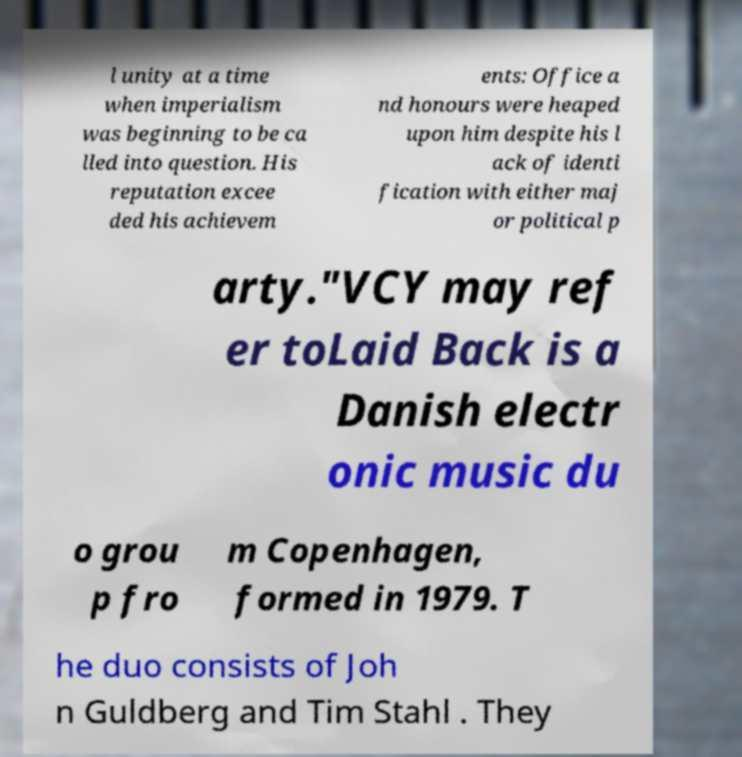There's text embedded in this image that I need extracted. Can you transcribe it verbatim? l unity at a time when imperialism was beginning to be ca lled into question. His reputation excee ded his achievem ents: Office a nd honours were heaped upon him despite his l ack of identi fication with either maj or political p arty."VCY may ref er toLaid Back is a Danish electr onic music du o grou p fro m Copenhagen, formed in 1979. T he duo consists of Joh n Guldberg and Tim Stahl . They 